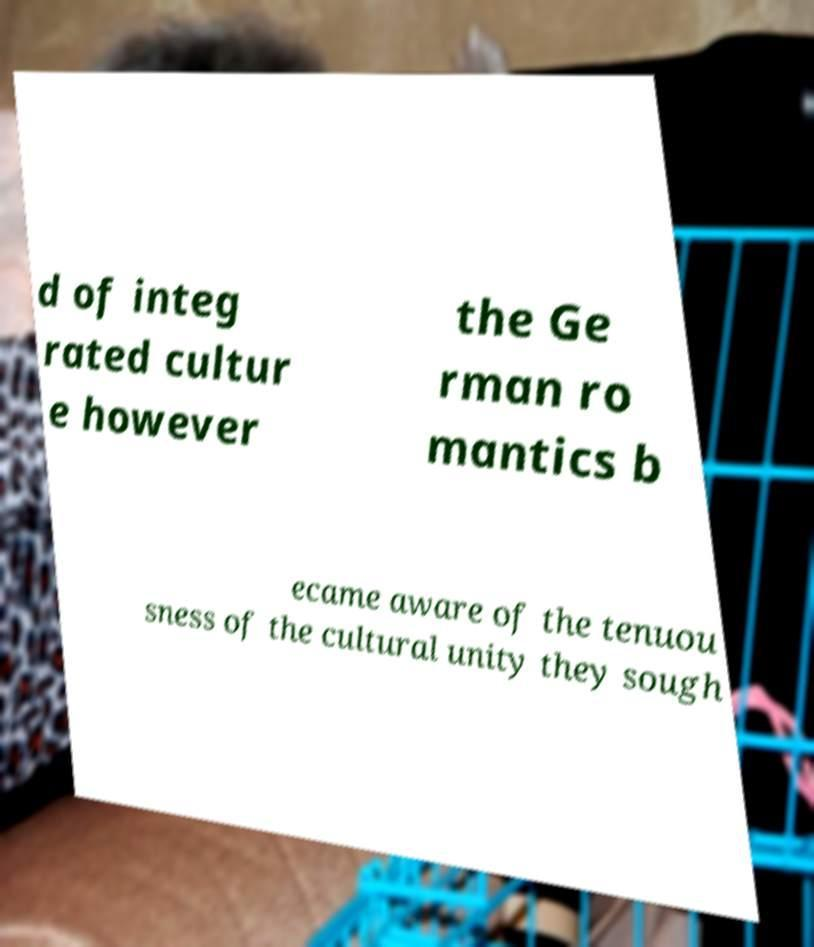There's text embedded in this image that I need extracted. Can you transcribe it verbatim? d of integ rated cultur e however the Ge rman ro mantics b ecame aware of the tenuou sness of the cultural unity they sough 